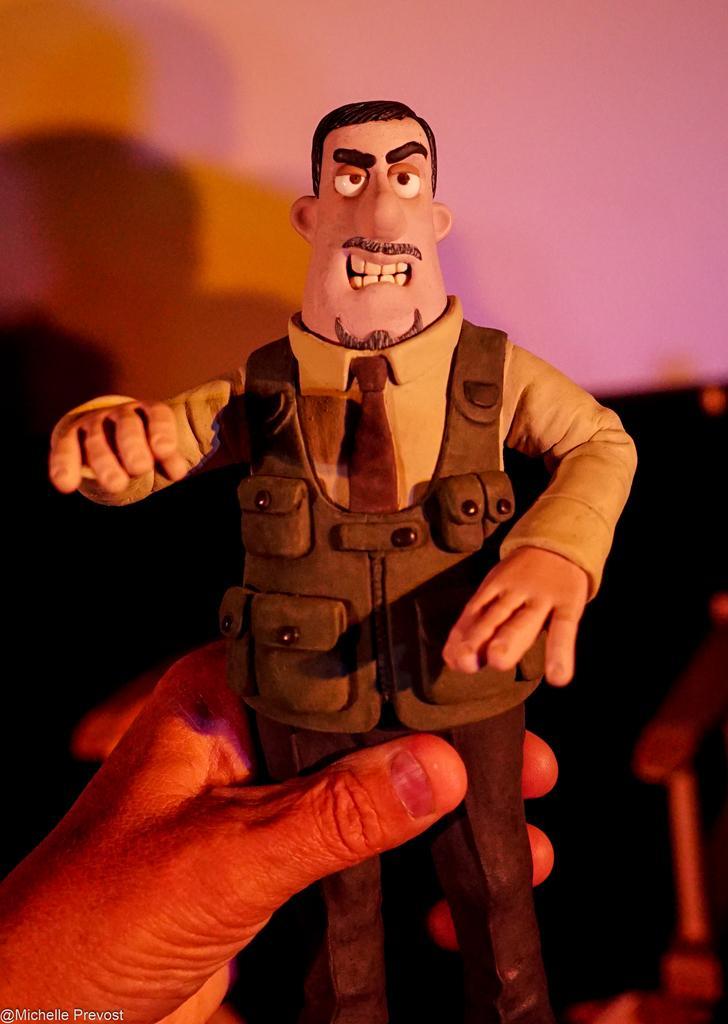Describe this image in one or two sentences. In this picture there is a small toy in the person hand. Behind there is a pink color wall. 